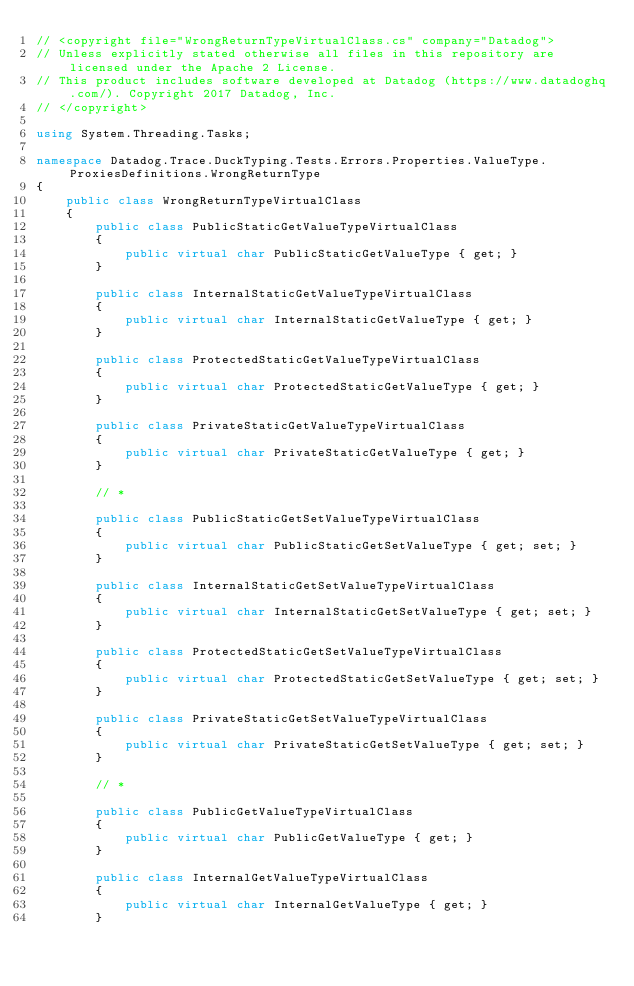Convert code to text. <code><loc_0><loc_0><loc_500><loc_500><_C#_>// <copyright file="WrongReturnTypeVirtualClass.cs" company="Datadog">
// Unless explicitly stated otherwise all files in this repository are licensed under the Apache 2 License.
// This product includes software developed at Datadog (https://www.datadoghq.com/). Copyright 2017 Datadog, Inc.
// </copyright>

using System.Threading.Tasks;

namespace Datadog.Trace.DuckTyping.Tests.Errors.Properties.ValueType.ProxiesDefinitions.WrongReturnType
{
    public class WrongReturnTypeVirtualClass
    {
        public class PublicStaticGetValueTypeVirtualClass
        {
            public virtual char PublicStaticGetValueType { get; }
        }

        public class InternalStaticGetValueTypeVirtualClass
        {
            public virtual char InternalStaticGetValueType { get; }
        }

        public class ProtectedStaticGetValueTypeVirtualClass
        {
            public virtual char ProtectedStaticGetValueType { get; }
        }

        public class PrivateStaticGetValueTypeVirtualClass
        {
            public virtual char PrivateStaticGetValueType { get; }
        }

        // *

        public class PublicStaticGetSetValueTypeVirtualClass
        {
            public virtual char PublicStaticGetSetValueType { get; set; }
        }

        public class InternalStaticGetSetValueTypeVirtualClass
        {
            public virtual char InternalStaticGetSetValueType { get; set; }
        }

        public class ProtectedStaticGetSetValueTypeVirtualClass
        {
            public virtual char ProtectedStaticGetSetValueType { get; set; }
        }

        public class PrivateStaticGetSetValueTypeVirtualClass
        {
            public virtual char PrivateStaticGetSetValueType { get; set; }
        }

        // *

        public class PublicGetValueTypeVirtualClass
        {
            public virtual char PublicGetValueType { get; }
        }

        public class InternalGetValueTypeVirtualClass
        {
            public virtual char InternalGetValueType { get; }
        }
</code> 